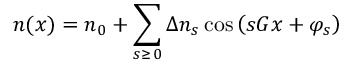<formula> <loc_0><loc_0><loc_500><loc_500>n ( x ) = n _ { 0 } + \sum _ { s \geq \, 0 } \Delta n _ { s } \cos { \left ( s G x + \varphi _ { s } \right ) }</formula> 